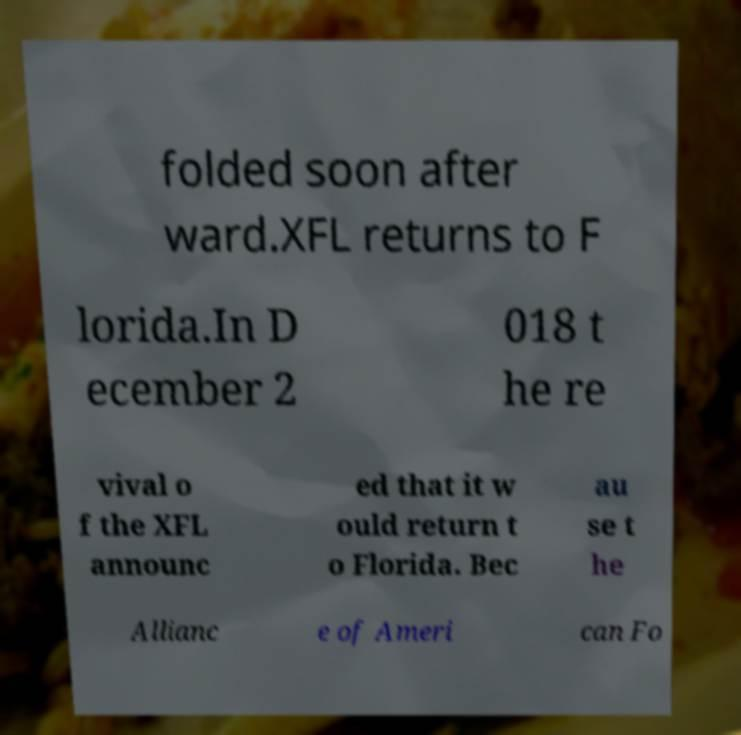I need the written content from this picture converted into text. Can you do that? folded soon after ward.XFL returns to F lorida.In D ecember 2 018 t he re vival o f the XFL announc ed that it w ould return t o Florida. Bec au se t he Allianc e of Ameri can Fo 